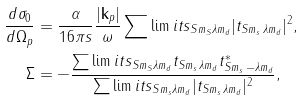<formula> <loc_0><loc_0><loc_500><loc_500>\frac { d \sigma _ { 0 } } { d \Omega _ { p } } & = \frac { \alpha } { 1 6 \pi s } \frac { | \mathbf k _ { p } | } { \omega } \sum \lim i t s _ { S m _ { S } \lambda m _ { d } } | t _ { S m _ { s } \, \lambda m _ { d } } | ^ { 2 } , \\ \Sigma & = - \frac { \sum \lim i t s _ { S m _ { S } \lambda m _ { d } } t _ { S m _ { s } \, \lambda m _ { d } } t _ { S m _ { s } \, - \lambda m _ { d } } ^ { * } } { \sum \lim i t s _ { S m _ { s } \lambda m _ { d } } | t _ { S m _ { s } \, \lambda m _ { d } } | ^ { 2 } } ,</formula> 